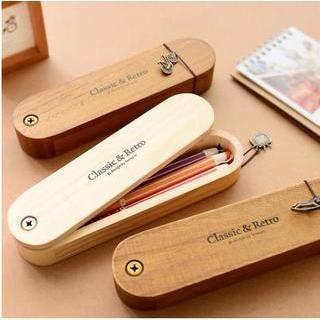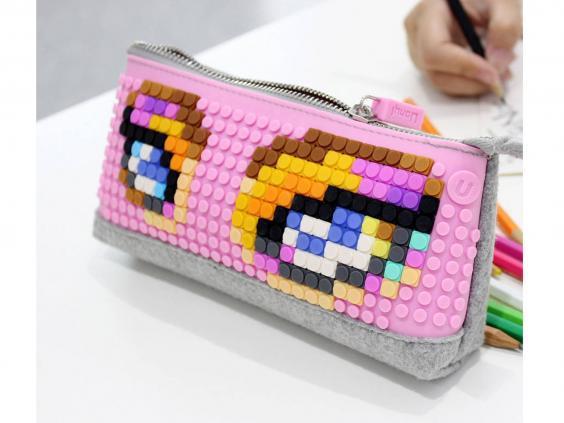The first image is the image on the left, the second image is the image on the right. Assess this claim about the two images: "The left image shows just one cyindrical pencil case.". Correct or not? Answer yes or no. No. 